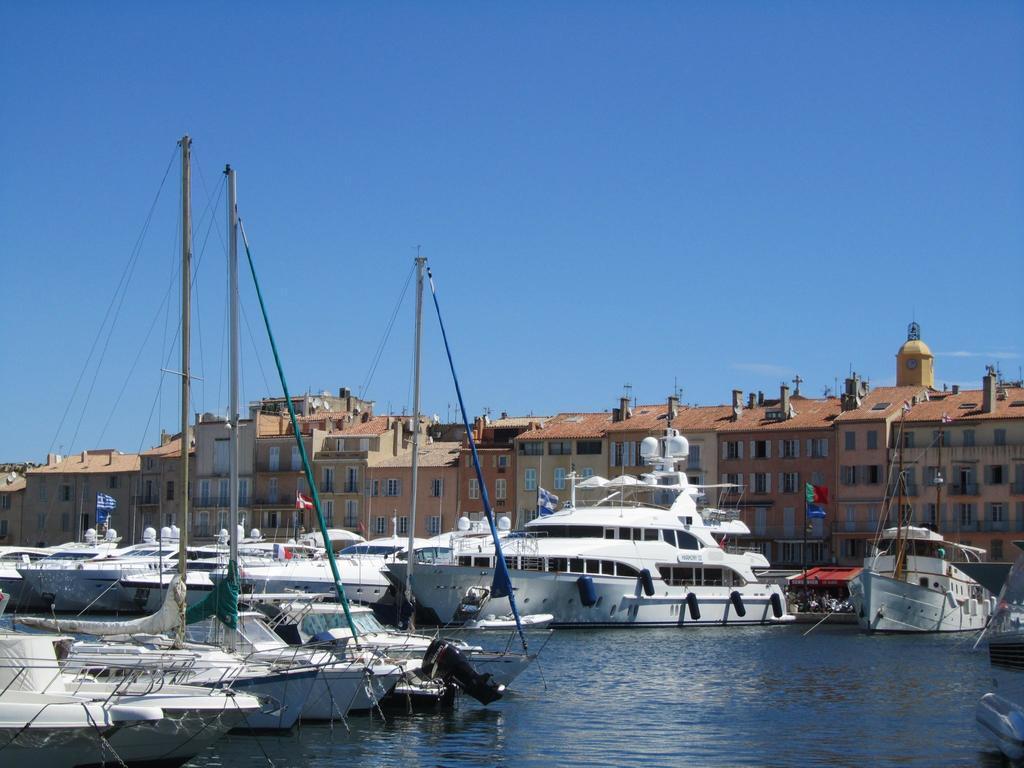Can you describe this image briefly? In this image I can see few boats. They are in white color. Back I can see buildings,glass windows and flags. I can see water. The sky is in blue and white color. 